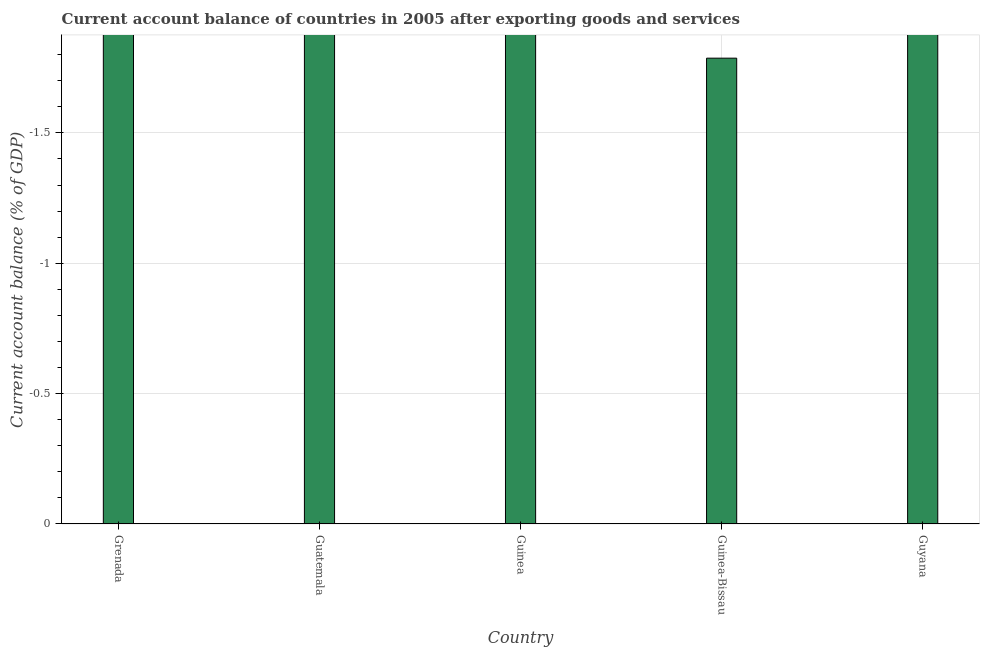Does the graph contain any zero values?
Give a very brief answer. Yes. Does the graph contain grids?
Your answer should be compact. Yes. What is the title of the graph?
Provide a succinct answer. Current account balance of countries in 2005 after exporting goods and services. What is the label or title of the Y-axis?
Ensure brevity in your answer.  Current account balance (% of GDP). What is the current account balance in Guyana?
Ensure brevity in your answer.  0. Across all countries, what is the minimum current account balance?
Give a very brief answer. 0. What is the average current account balance per country?
Your answer should be compact. 0. What is the median current account balance?
Provide a succinct answer. 0. In how many countries, is the current account balance greater than -0.7 %?
Your answer should be very brief. 0. In how many countries, is the current account balance greater than the average current account balance taken over all countries?
Give a very brief answer. 0. How many countries are there in the graph?
Provide a short and direct response. 5. What is the Current account balance (% of GDP) of Guinea-Bissau?
Give a very brief answer. 0. What is the Current account balance (% of GDP) of Guyana?
Provide a succinct answer. 0. 